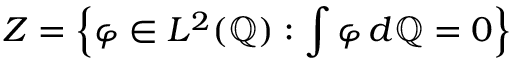Convert formula to latex. <formula><loc_0><loc_0><loc_500><loc_500>Z = \left \{ \varphi \in L ^ { 2 } ( \mathbb { Q } ) \colon \int \varphi \, d \mathbb { Q } = 0 \right \}</formula> 